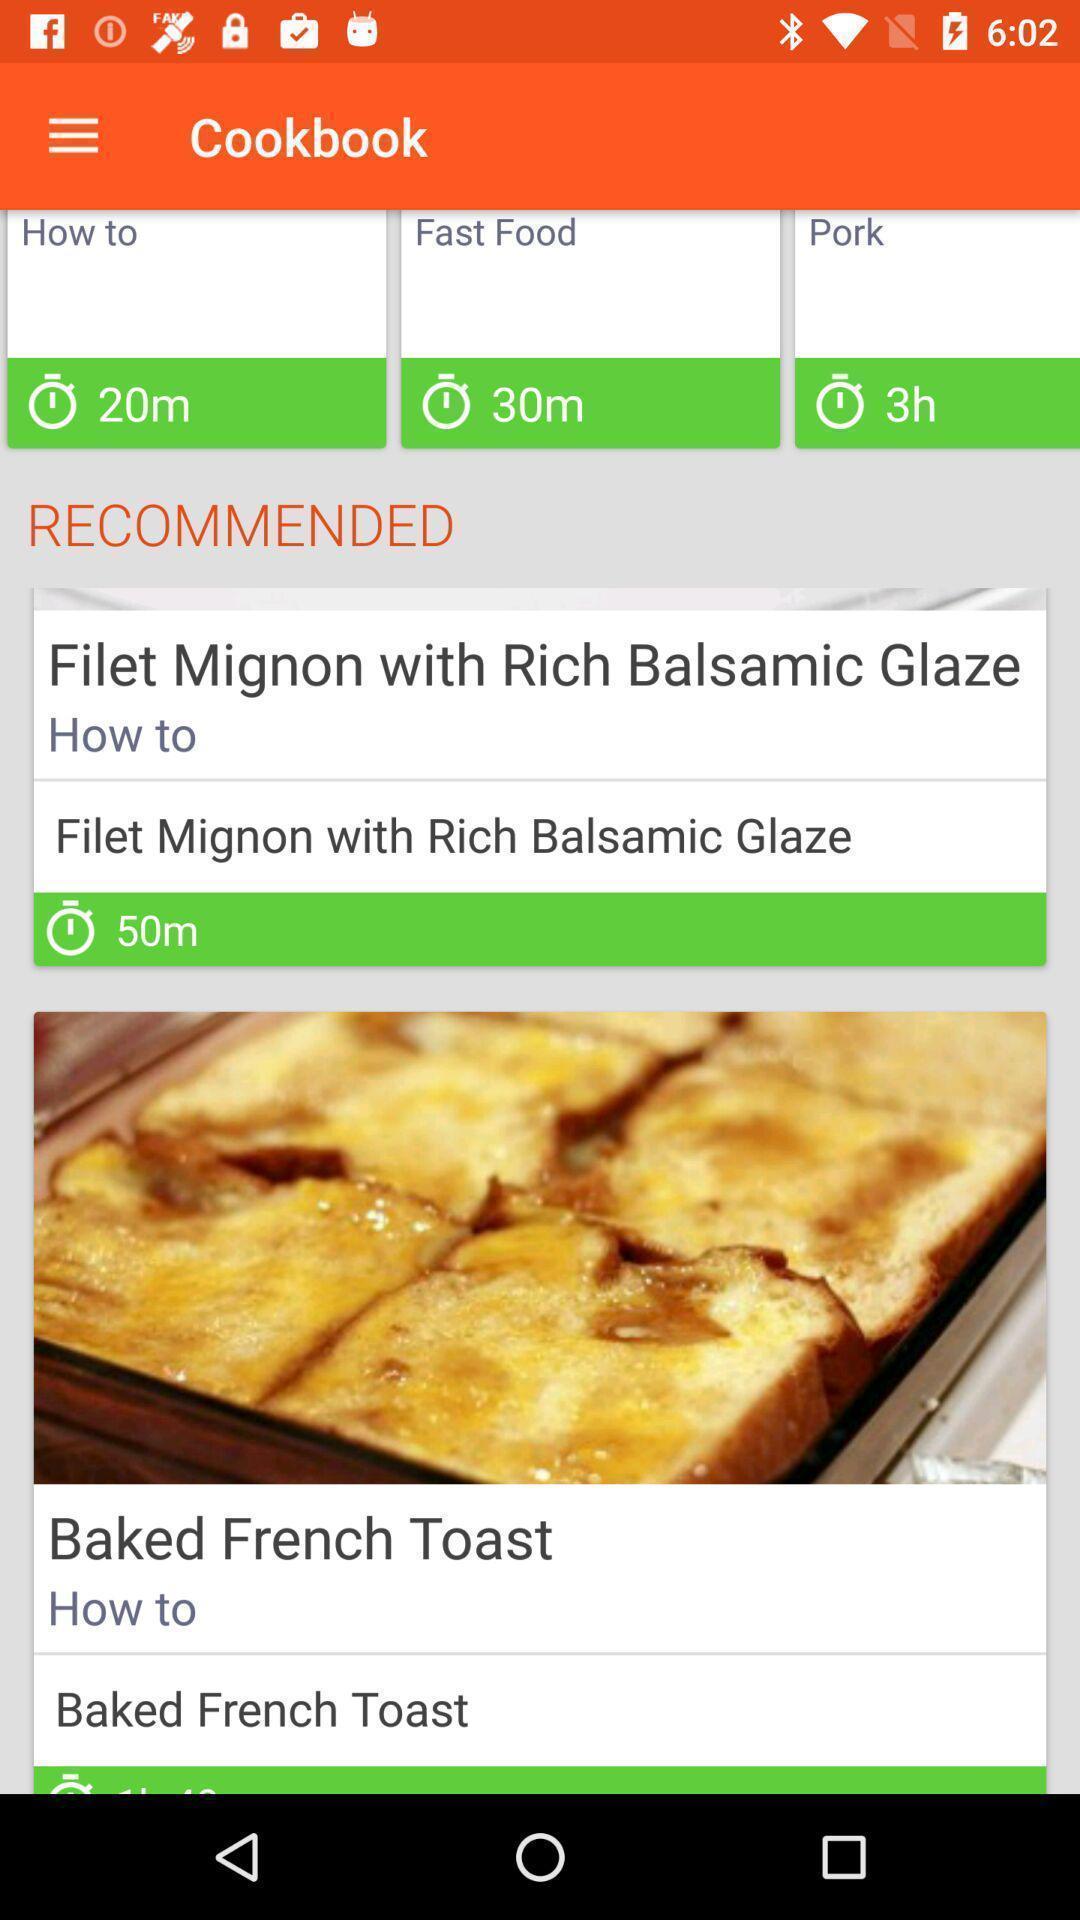Provide a detailed account of this screenshot. Screen shows multiple recipes in a food app. 